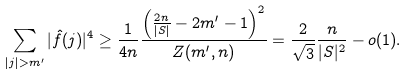Convert formula to latex. <formula><loc_0><loc_0><loc_500><loc_500>\sum _ { | j | > m ^ { \prime } } | \hat { f } ( j ) | ^ { 4 } \geq \frac { 1 } { 4 n } \frac { \left ( \frac { 2 n } { | S | } - 2 m ^ { \prime } - 1 \right ) ^ { 2 } } { Z ( m ^ { \prime } , n ) } = \frac { 2 } { \sqrt { 3 } } \frac { n } { | S | ^ { 2 } } - o ( 1 ) .</formula> 